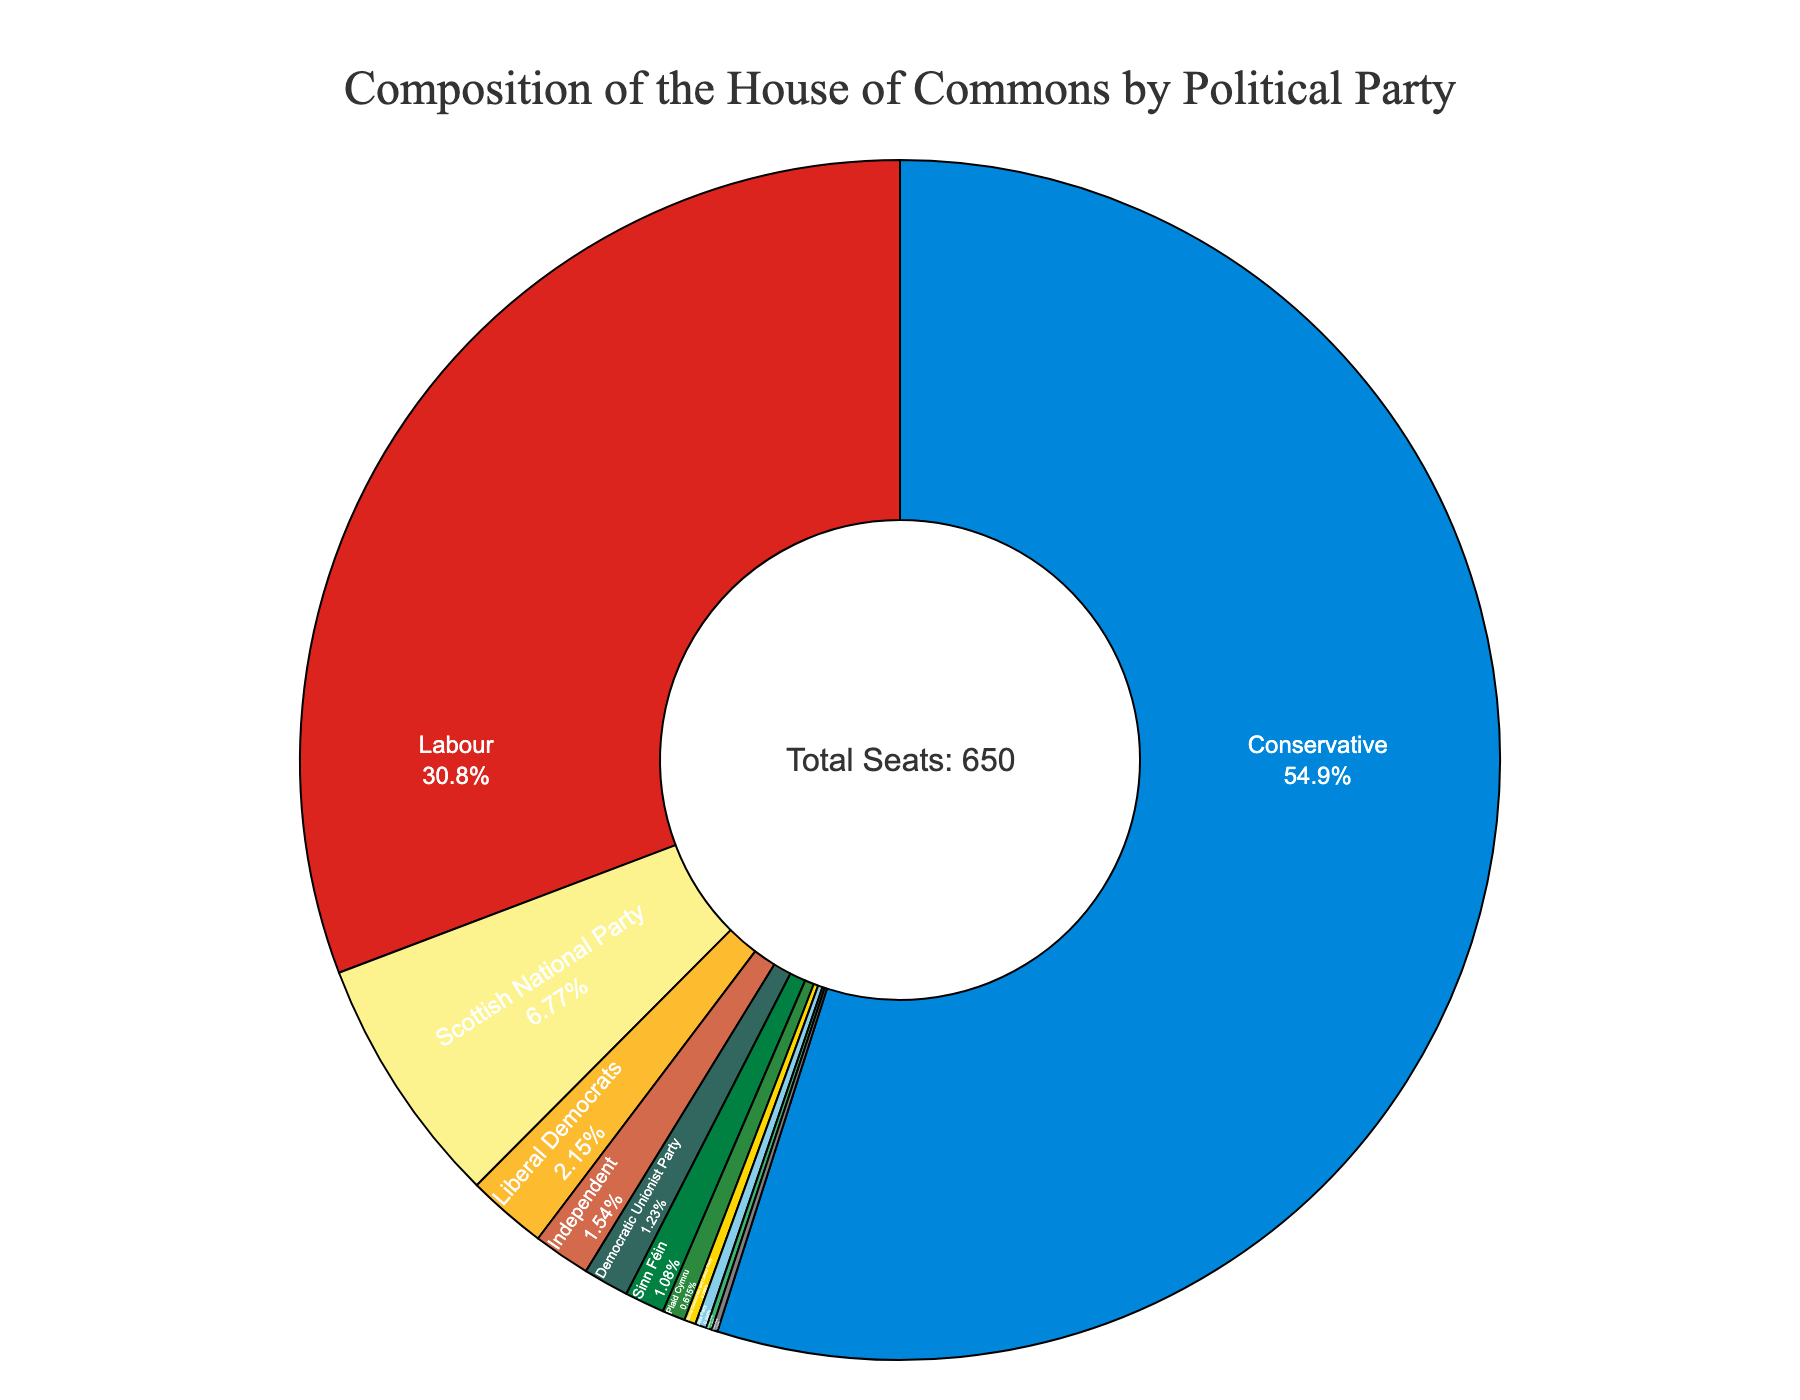Which party has the highest number of seats? The figure shows that the Conservative Party has the largest segment of the pie chart. The label indicates that the Conservative Party has 357 seats.
Answer: Conservative Party Which political party has the smallest representation? The figure includes a small segment labeled as the Green Party, which has only 1 seat.
Answer: Green Party How many more seats does the Conservative Party have compared to Labour? The Conservative Party has 357 seats while the Labour Party has 200 seats. The difference between them is 357 - 200 = 157 seats.
Answer: 157 seats What is the combined number of seats held by the Scottish National Party, Liberal Democrats, and Democratic Unionist Party? From the chart, the Scottish National Party has 44 seats, the Liberal Democrats have 14 seats and the Democratic Unionist Party has 8 seats. Adding these together, we get 44 + 14 + 8 = 66 seats.
Answer: 66 seats Which is the third largest party in the House of Commons by seats? Observing the pie chart, after the Conservative and Labour parties, the next largest segment is for the Scottish National Party with 44 seats.
Answer: Scottish National Party What percentage of total seats do the Liberal Democrats hold? The Liberal Democrats have 14 seats out of a total of 650. To find the percentage, we use (14 / 650) * 100 which equals approximately 2.15%.
Answer: Approximately 2.15% How many seats in total are held by parties other than Conservative and Labour? The total seats of the House of Commons are 650. Conservative and Labour have 357 and 200 seats respectively. Therefore, subtracting their seats from the total gives 650 - 357 - 200 = 93 seats.
Answer: 93 seats What is the color representing the Plaid Cymru on the figure? Observing the pie chart, the segment labeled as Plaid Cymru is colored in green.
Answer: Green Compare the seats of Sinn Féin and Independents. Which is higher? The pie chart shows that Sinn Féin has 7 seats while Independents have 10 seats. Therefore, Independents have more seats than Sinn Féin.
Answer: Independents What is the sum of seats of all parties holding less than 10 seats each? The parties holding less than 10 seats are the Democratic Unionist Party (8), Sinn Féin (7), Plaid Cymru (4), Social Democratic and Labour Party (2), Alba Party (2), Alliance Party (1), Green Party (1). Adding these gives 8 + 7 + 4 + 2 + 2 + 1 + 1 = 25 seats.
Answer: 25 seats 